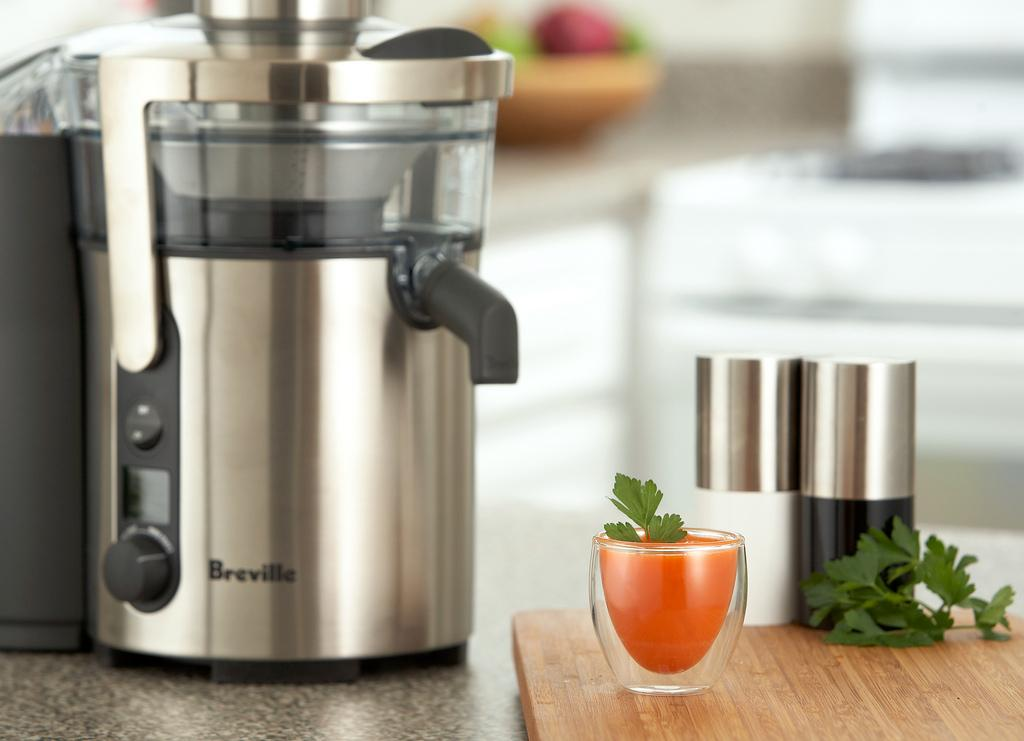<image>
Share a concise interpretation of the image provided. A chromed juice maker of the Breville brand and a shot glass with carrot juice in it. 